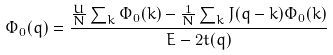Convert formula to latex. <formula><loc_0><loc_0><loc_500><loc_500>\Phi _ { 0 } ( q ) = \frac { \frac { U } { N } \sum _ { k } \Phi _ { 0 } ( k ) - \frac { 1 } { N } \sum _ { k } J ( q - k ) \Phi _ { 0 } ( k ) } { E - 2 t ( q ) }</formula> 